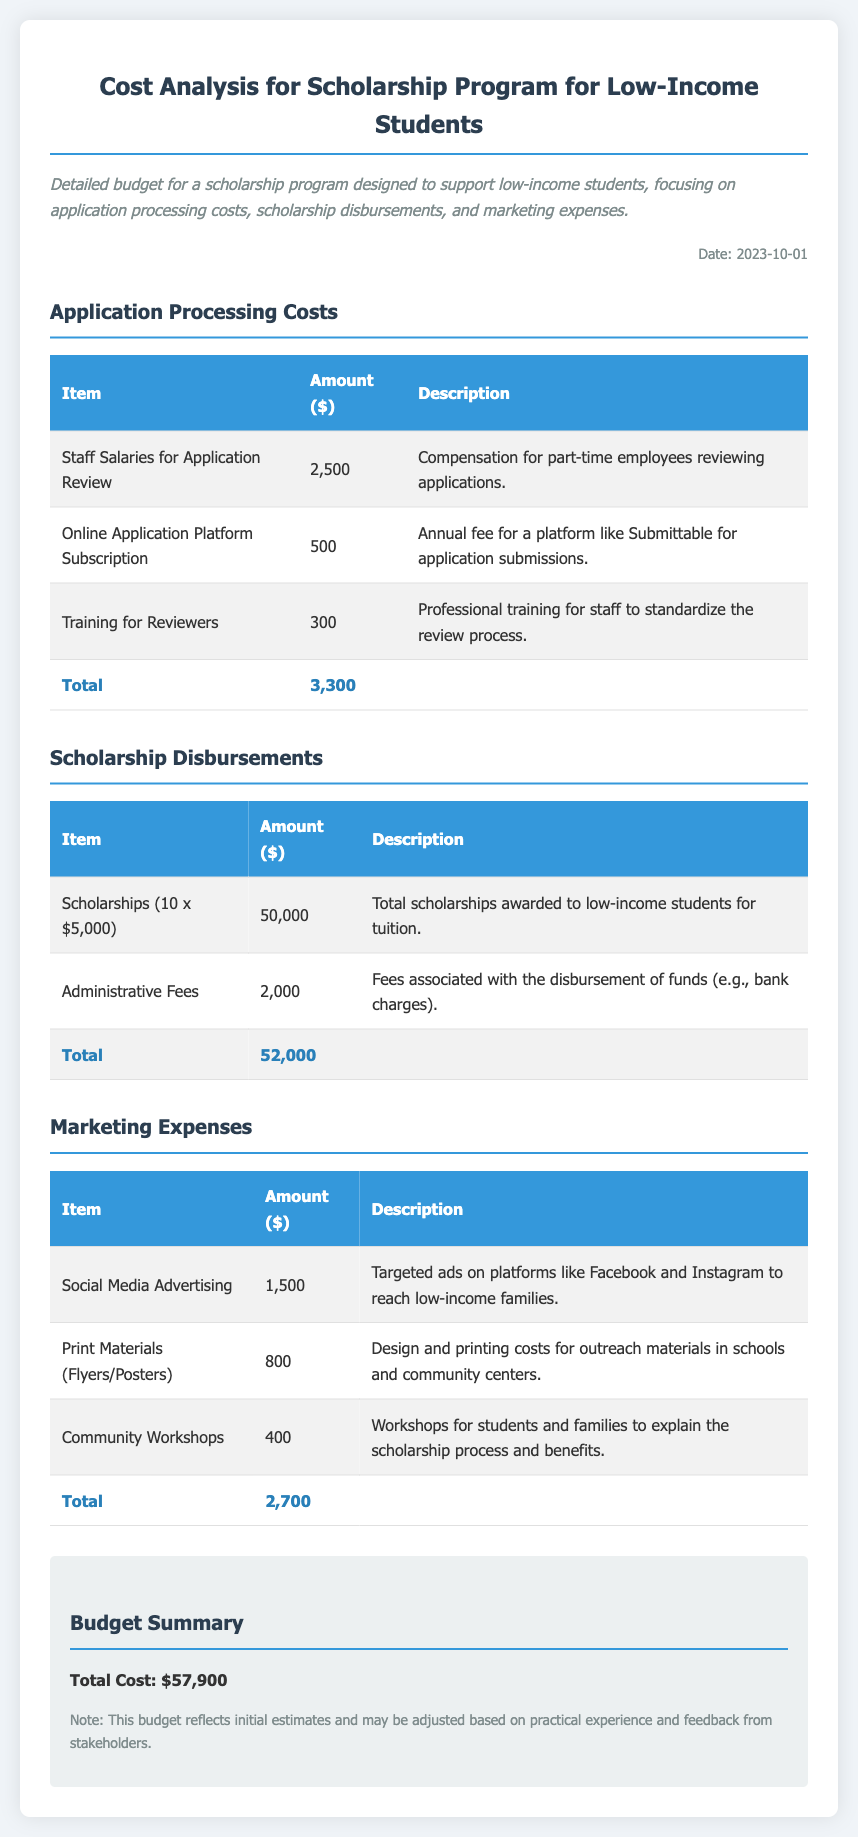What is the total amount for application processing costs? The total amount for application processing costs is summarized in the budget, which is $3,300.
Answer: $3,300 How many scholarships are awarded? The document states that 10 scholarships are awarded to low-income students.
Answer: 10 What is the cost of social media advertising? Social media advertising costs are detailed in the marketing expenses section as $1,500.
Answer: $1,500 What are the administrative fees related to scholarship disbursements? The administrative fees associated with disbursement is mentioned in the scholarship disbursements section, which is $2,000.
Answer: $2,000 How much is budgeted for the entire scholarship program? The total cost for the scholarship program is clearly outlined in the budget summary as $57,900.
Answer: $57,900 What type of training is included in the application processing costs? The type of training mentioned is professional training for staff to standardize the review process.
Answer: Training for Reviewers What is the expense for print materials? The expense for print materials, as mentioned in the marketing section, is $800.
Answer: $800 What is the total amount for scholarship disbursements? The total amount for scholarship disbursements is described in the budget as $52,000.
Answer: $52,000 What is included in the community workshops budget line? The community workshops budget line includes workshops for students and families to explain the scholarship process and benefits.
Answer: Community Workshops 